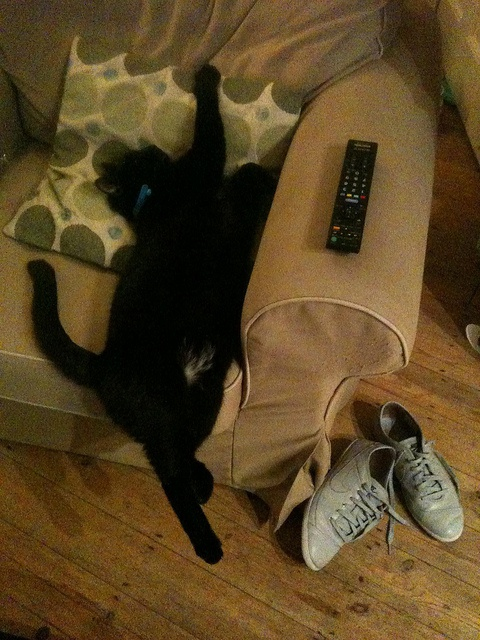Describe the objects in this image and their specific colors. I can see couch in black and olive tones, cat in black and olive tones, and remote in black, darkgreen, gray, and maroon tones in this image. 